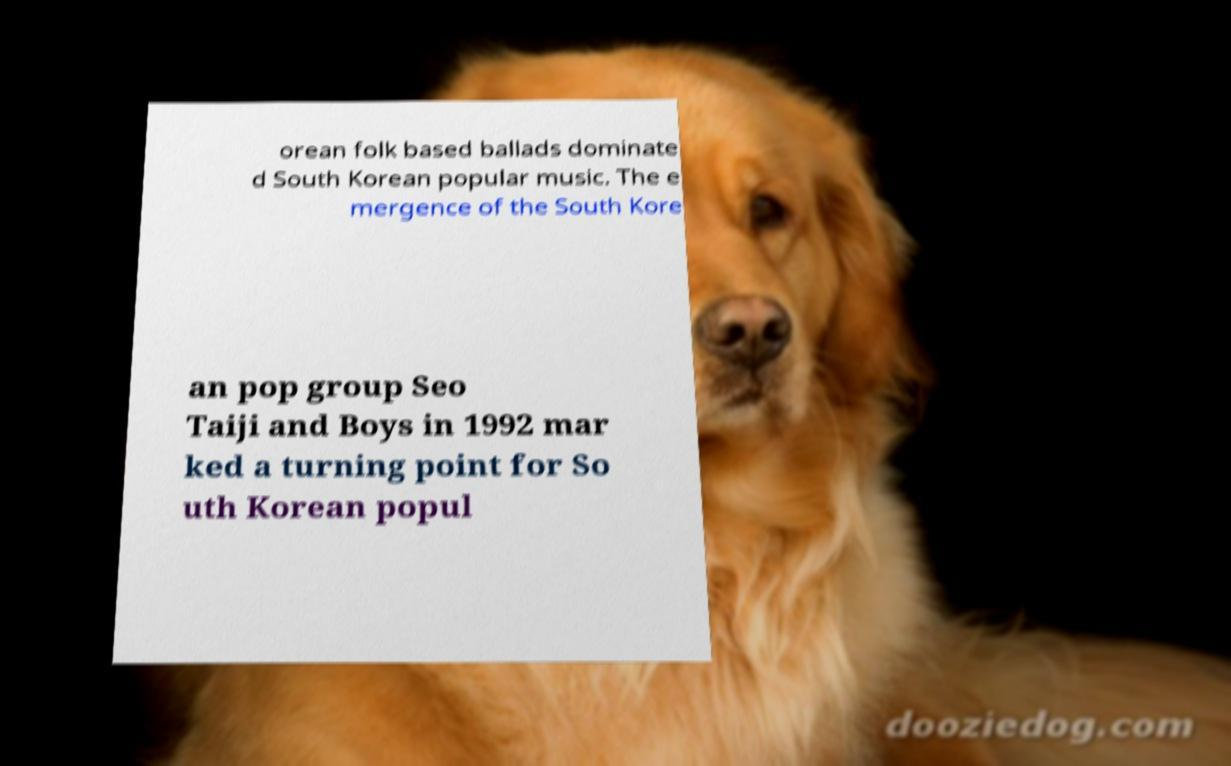Could you assist in decoding the text presented in this image and type it out clearly? orean folk based ballads dominate d South Korean popular music. The e mergence of the South Kore an pop group Seo Taiji and Boys in 1992 mar ked a turning point for So uth Korean popul 